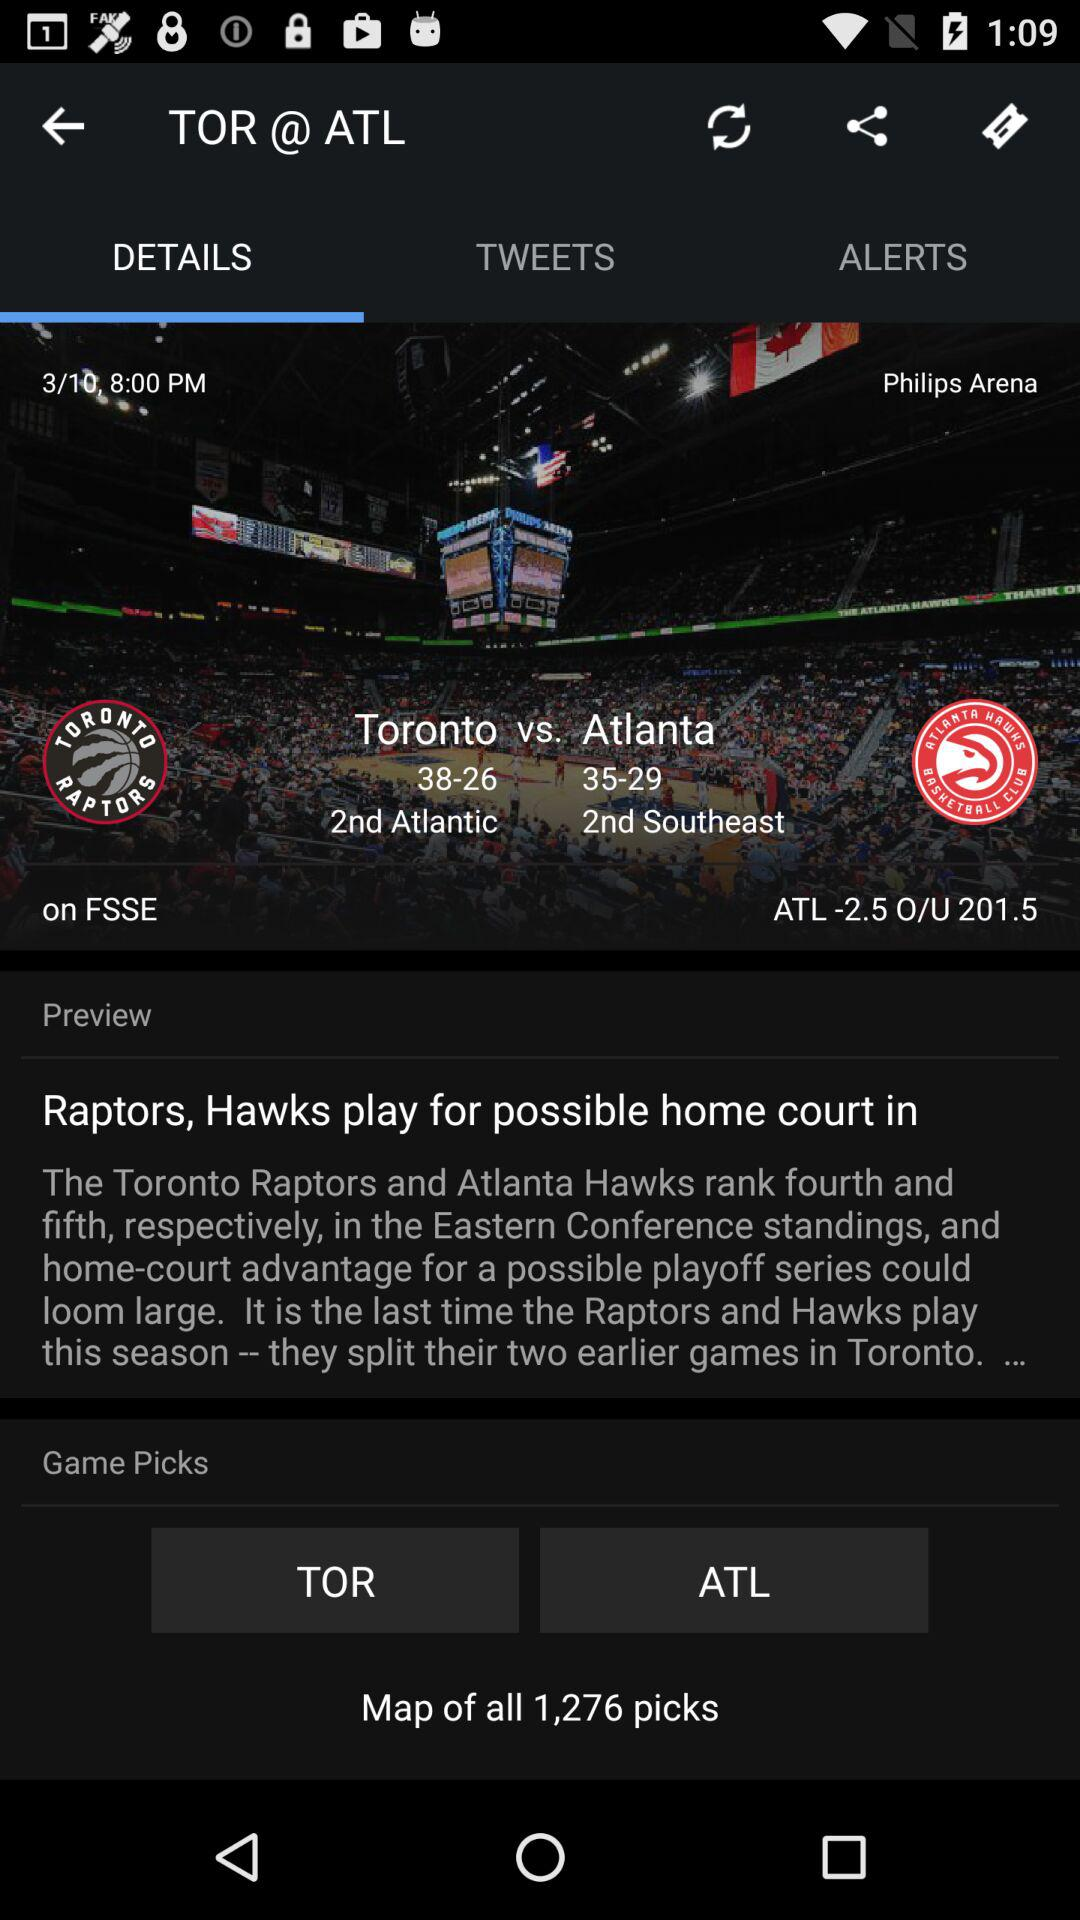What is the over/under for this game?
Answer the question using a single word or phrase. 201.5 